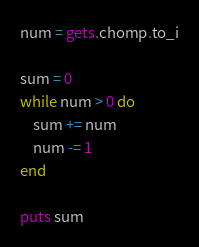<code> <loc_0><loc_0><loc_500><loc_500><_Ruby_>num = gets.chomp.to_i

sum = 0
while num > 0 do
    sum += num 
    num -= 1
end

puts sum</code> 